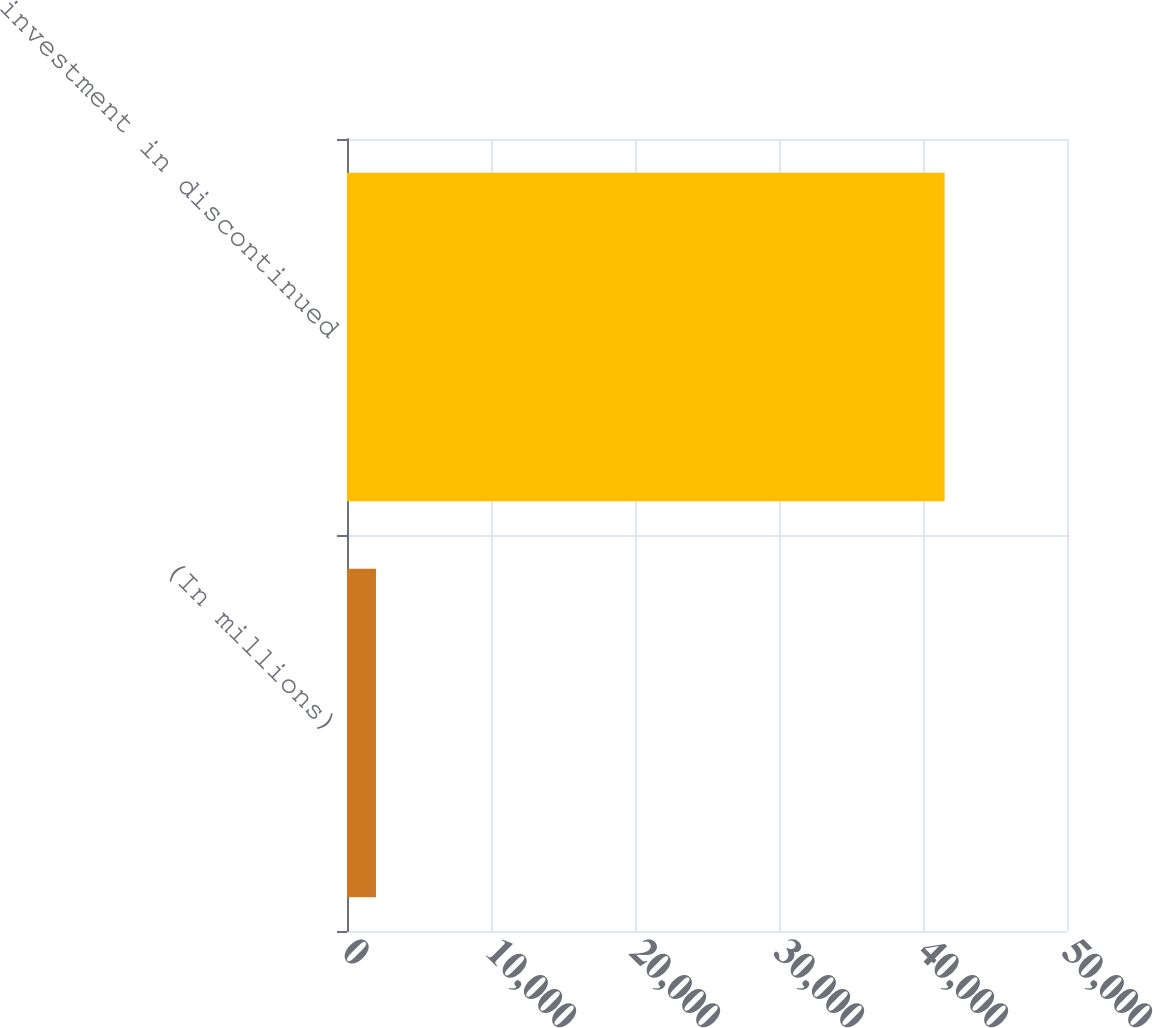Convert chart. <chart><loc_0><loc_0><loc_500><loc_500><bar_chart><fcel>(In millions)<fcel>investment in discontinued<nl><fcel>2012<fcel>41504<nl></chart> 